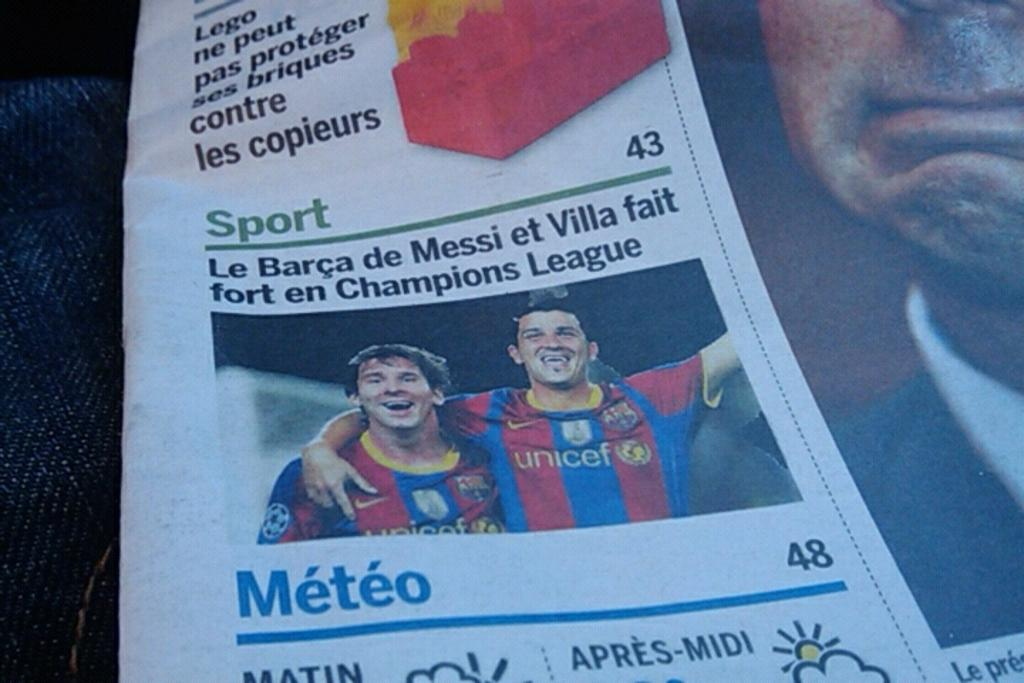What type of content is featured in the newspaper article in the image? There is a newspaper article on sports in the image. How many people are present in the image? Two players are standing in the image. What is the facial expression of the players in the image? The players are smiling in the image. What type of chin can be seen on the bridge in the image? There is no chin or bridge present in the image; it features a newspaper article on sports and two players. How does the father interact with the players in the image? There is no father present in the image; it only features the two players and the newspaper article. 